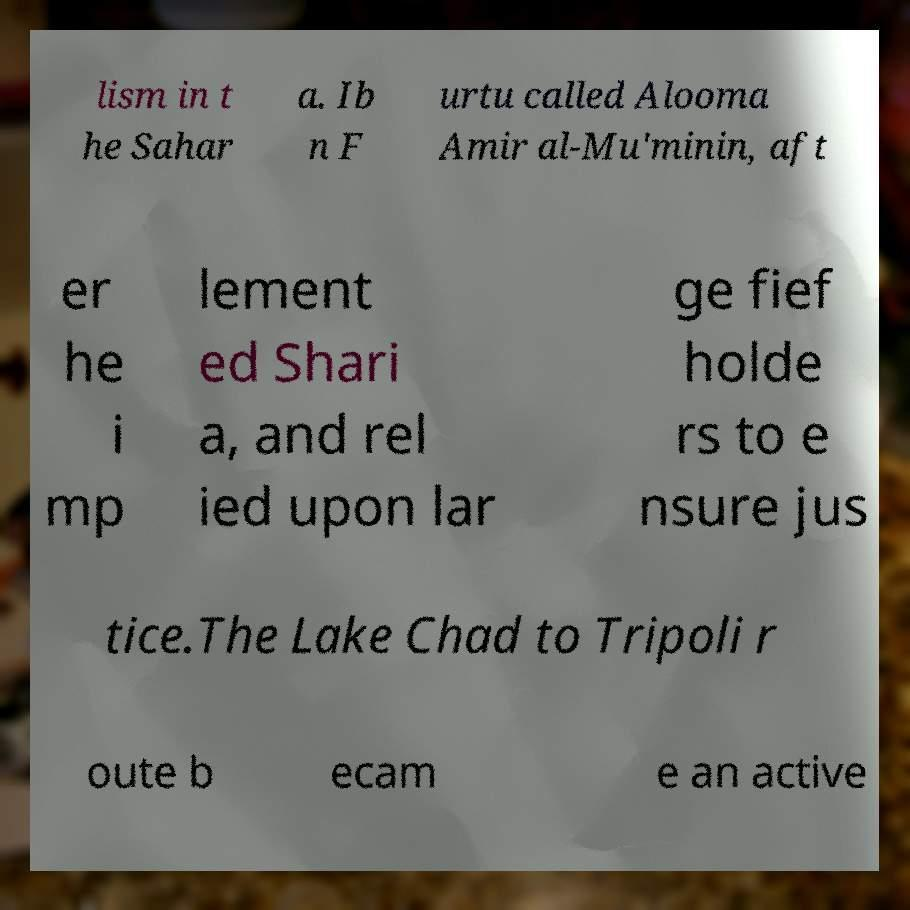For documentation purposes, I need the text within this image transcribed. Could you provide that? lism in t he Sahar a. Ib n F urtu called Alooma Amir al-Mu'minin, aft er he i mp lement ed Shari a, and rel ied upon lar ge fief holde rs to e nsure jus tice.The Lake Chad to Tripoli r oute b ecam e an active 